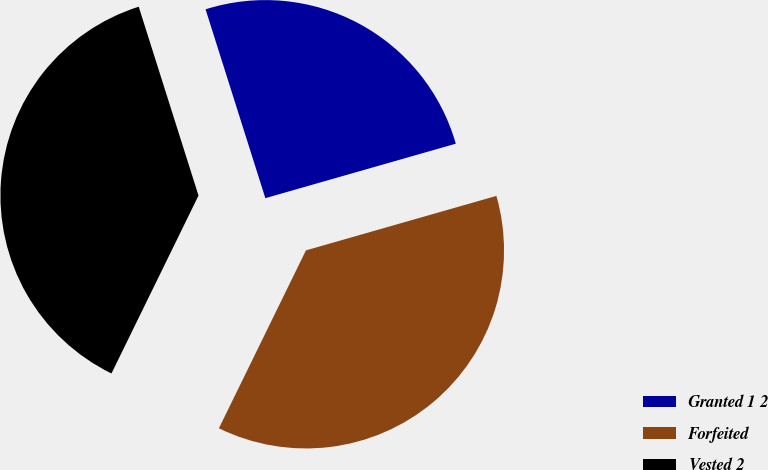Convert chart to OTSL. <chart><loc_0><loc_0><loc_500><loc_500><pie_chart><fcel>Granted 1 2<fcel>Forfeited<fcel>Vested 2<nl><fcel>25.45%<fcel>36.68%<fcel>37.88%<nl></chart> 